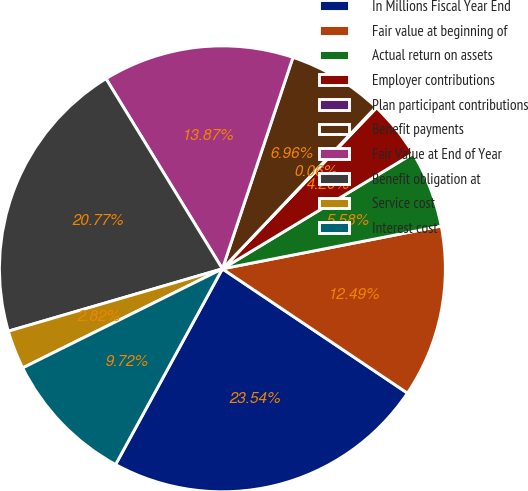Convert chart. <chart><loc_0><loc_0><loc_500><loc_500><pie_chart><fcel>In Millions Fiscal Year End<fcel>Fair value at beginning of<fcel>Actual return on assets<fcel>Employer contributions<fcel>Plan participant contributions<fcel>Benefit payments<fcel>Fair Value at End of Year<fcel>Benefit obligation at<fcel>Service cost<fcel>Interest cost<nl><fcel>23.54%<fcel>12.49%<fcel>5.58%<fcel>4.2%<fcel>0.06%<fcel>6.96%<fcel>13.87%<fcel>20.77%<fcel>2.82%<fcel>9.72%<nl></chart> 